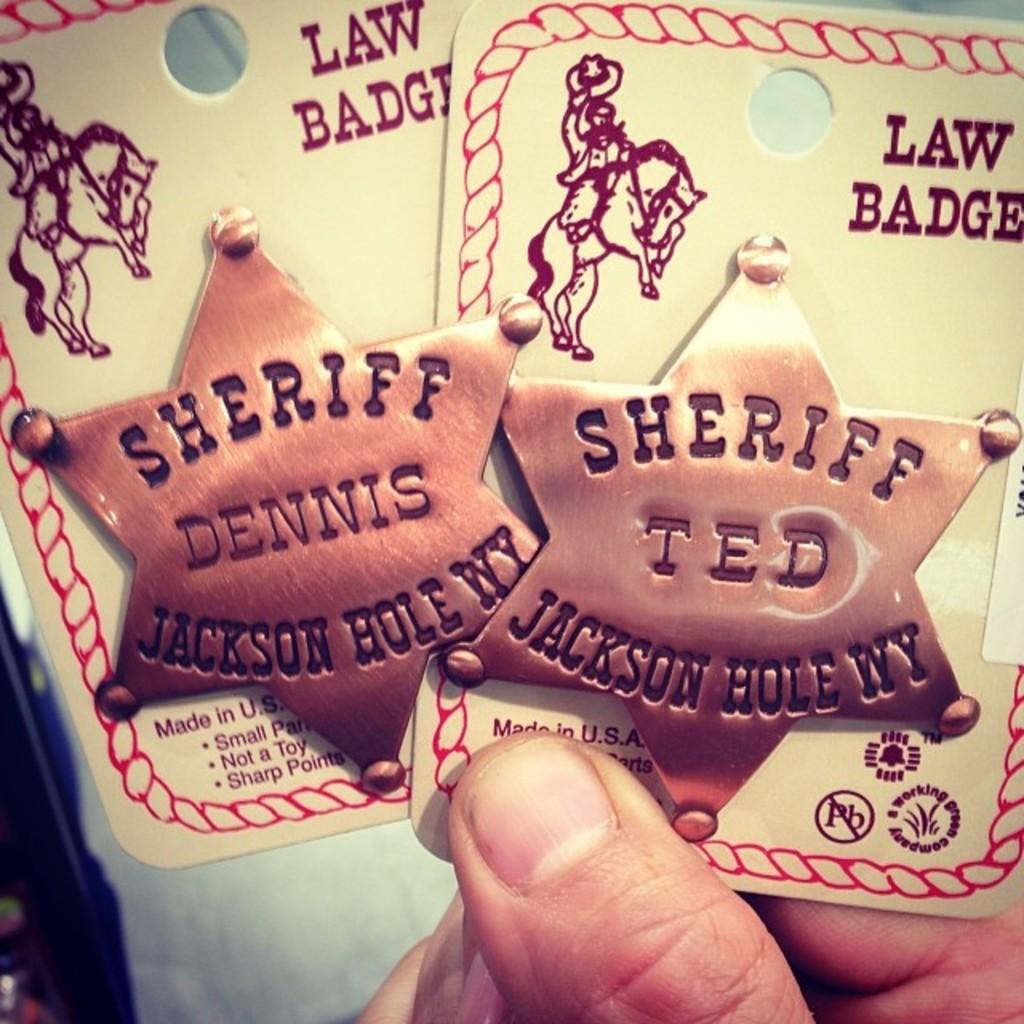What part of a person can be seen in the image? There are fingers of a person visible in the image. What is the person holding in their hand? The person is holding two white color things. Can you describe the appearance of these white things? There is writing on these white things. What type of soup is being prepared by the person in the image? There is no soup present in the image; the person is holding two white things with writing on them. 